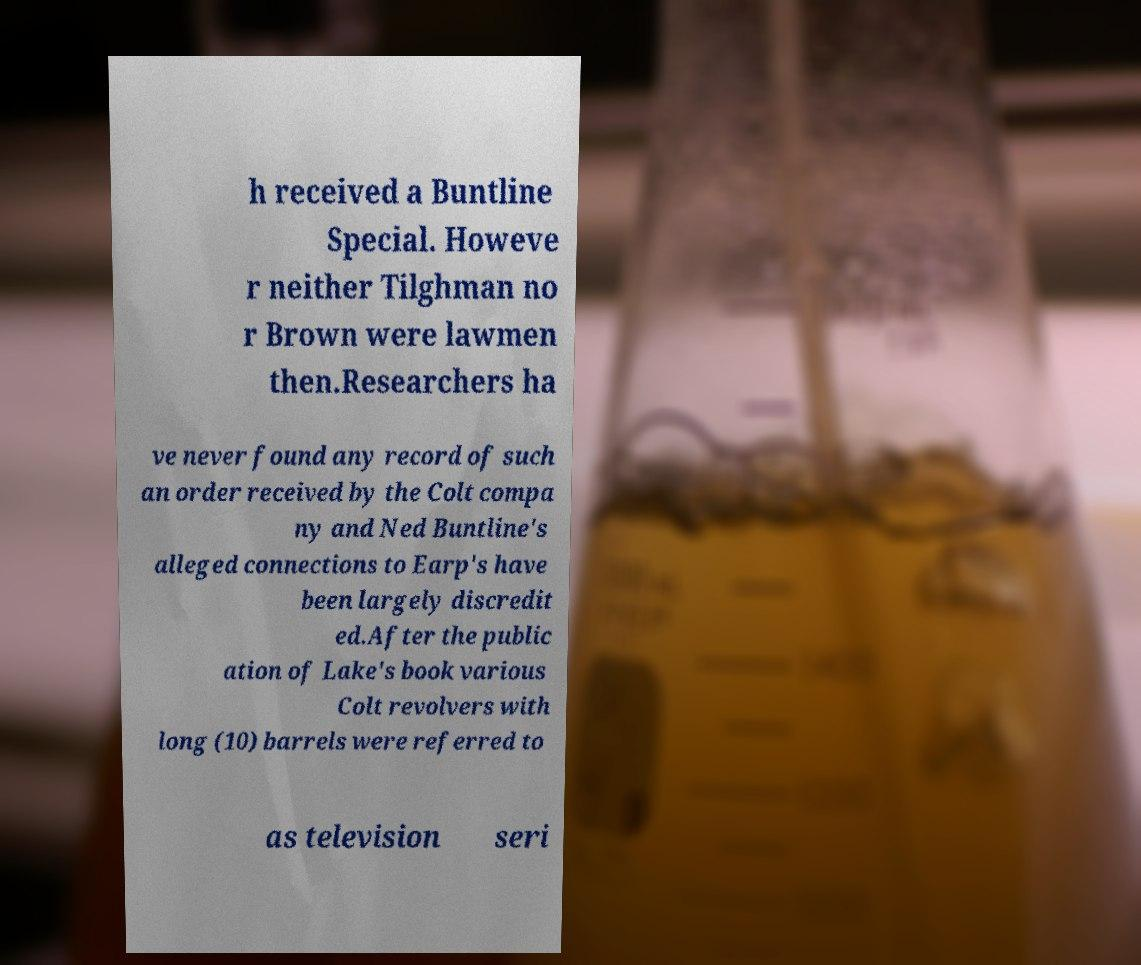Can you accurately transcribe the text from the provided image for me? h received a Buntline Special. Howeve r neither Tilghman no r Brown were lawmen then.Researchers ha ve never found any record of such an order received by the Colt compa ny and Ned Buntline's alleged connections to Earp's have been largely discredit ed.After the public ation of Lake's book various Colt revolvers with long (10) barrels were referred to as television seri 